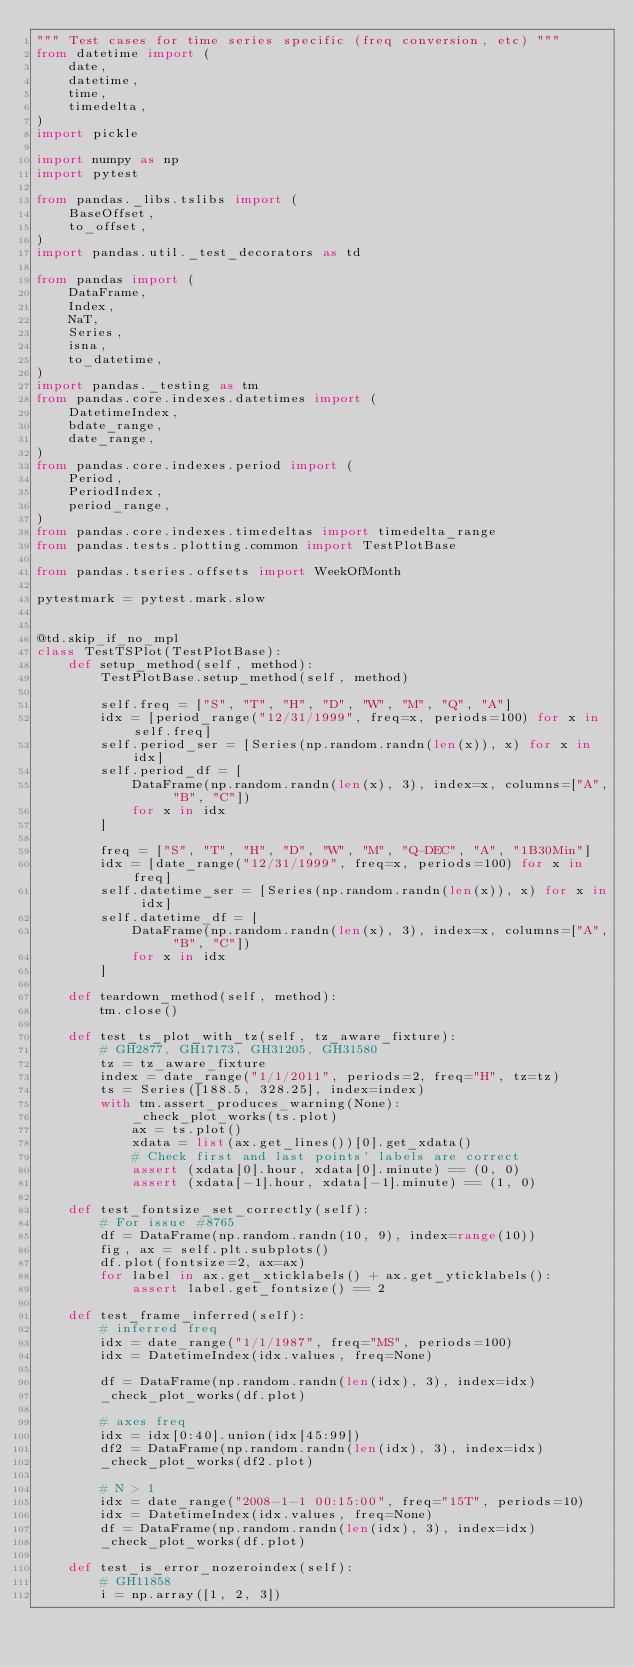<code> <loc_0><loc_0><loc_500><loc_500><_Python_>""" Test cases for time series specific (freq conversion, etc) """
from datetime import (
    date,
    datetime,
    time,
    timedelta,
)
import pickle

import numpy as np
import pytest

from pandas._libs.tslibs import (
    BaseOffset,
    to_offset,
)
import pandas.util._test_decorators as td

from pandas import (
    DataFrame,
    Index,
    NaT,
    Series,
    isna,
    to_datetime,
)
import pandas._testing as tm
from pandas.core.indexes.datetimes import (
    DatetimeIndex,
    bdate_range,
    date_range,
)
from pandas.core.indexes.period import (
    Period,
    PeriodIndex,
    period_range,
)
from pandas.core.indexes.timedeltas import timedelta_range
from pandas.tests.plotting.common import TestPlotBase

from pandas.tseries.offsets import WeekOfMonth

pytestmark = pytest.mark.slow


@td.skip_if_no_mpl
class TestTSPlot(TestPlotBase):
    def setup_method(self, method):
        TestPlotBase.setup_method(self, method)

        self.freq = ["S", "T", "H", "D", "W", "M", "Q", "A"]
        idx = [period_range("12/31/1999", freq=x, periods=100) for x in self.freq]
        self.period_ser = [Series(np.random.randn(len(x)), x) for x in idx]
        self.period_df = [
            DataFrame(np.random.randn(len(x), 3), index=x, columns=["A", "B", "C"])
            for x in idx
        ]

        freq = ["S", "T", "H", "D", "W", "M", "Q-DEC", "A", "1B30Min"]
        idx = [date_range("12/31/1999", freq=x, periods=100) for x in freq]
        self.datetime_ser = [Series(np.random.randn(len(x)), x) for x in idx]
        self.datetime_df = [
            DataFrame(np.random.randn(len(x), 3), index=x, columns=["A", "B", "C"])
            for x in idx
        ]

    def teardown_method(self, method):
        tm.close()

    def test_ts_plot_with_tz(self, tz_aware_fixture):
        # GH2877, GH17173, GH31205, GH31580
        tz = tz_aware_fixture
        index = date_range("1/1/2011", periods=2, freq="H", tz=tz)
        ts = Series([188.5, 328.25], index=index)
        with tm.assert_produces_warning(None):
            _check_plot_works(ts.plot)
            ax = ts.plot()
            xdata = list(ax.get_lines())[0].get_xdata()
            # Check first and last points' labels are correct
            assert (xdata[0].hour, xdata[0].minute) == (0, 0)
            assert (xdata[-1].hour, xdata[-1].minute) == (1, 0)

    def test_fontsize_set_correctly(self):
        # For issue #8765
        df = DataFrame(np.random.randn(10, 9), index=range(10))
        fig, ax = self.plt.subplots()
        df.plot(fontsize=2, ax=ax)
        for label in ax.get_xticklabels() + ax.get_yticklabels():
            assert label.get_fontsize() == 2

    def test_frame_inferred(self):
        # inferred freq
        idx = date_range("1/1/1987", freq="MS", periods=100)
        idx = DatetimeIndex(idx.values, freq=None)

        df = DataFrame(np.random.randn(len(idx), 3), index=idx)
        _check_plot_works(df.plot)

        # axes freq
        idx = idx[0:40].union(idx[45:99])
        df2 = DataFrame(np.random.randn(len(idx), 3), index=idx)
        _check_plot_works(df2.plot)

        # N > 1
        idx = date_range("2008-1-1 00:15:00", freq="15T", periods=10)
        idx = DatetimeIndex(idx.values, freq=None)
        df = DataFrame(np.random.randn(len(idx), 3), index=idx)
        _check_plot_works(df.plot)

    def test_is_error_nozeroindex(self):
        # GH11858
        i = np.array([1, 2, 3])</code> 